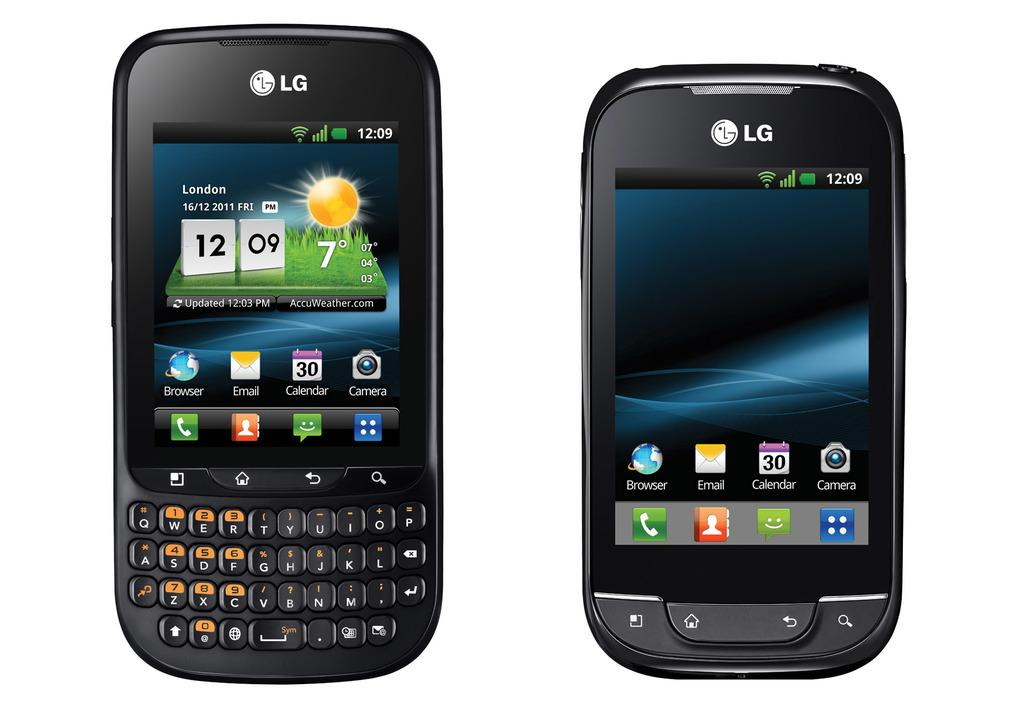<image>
Give a short and clear explanation of the subsequent image. The phone screen gives the location of London and the date and time it currently is. 